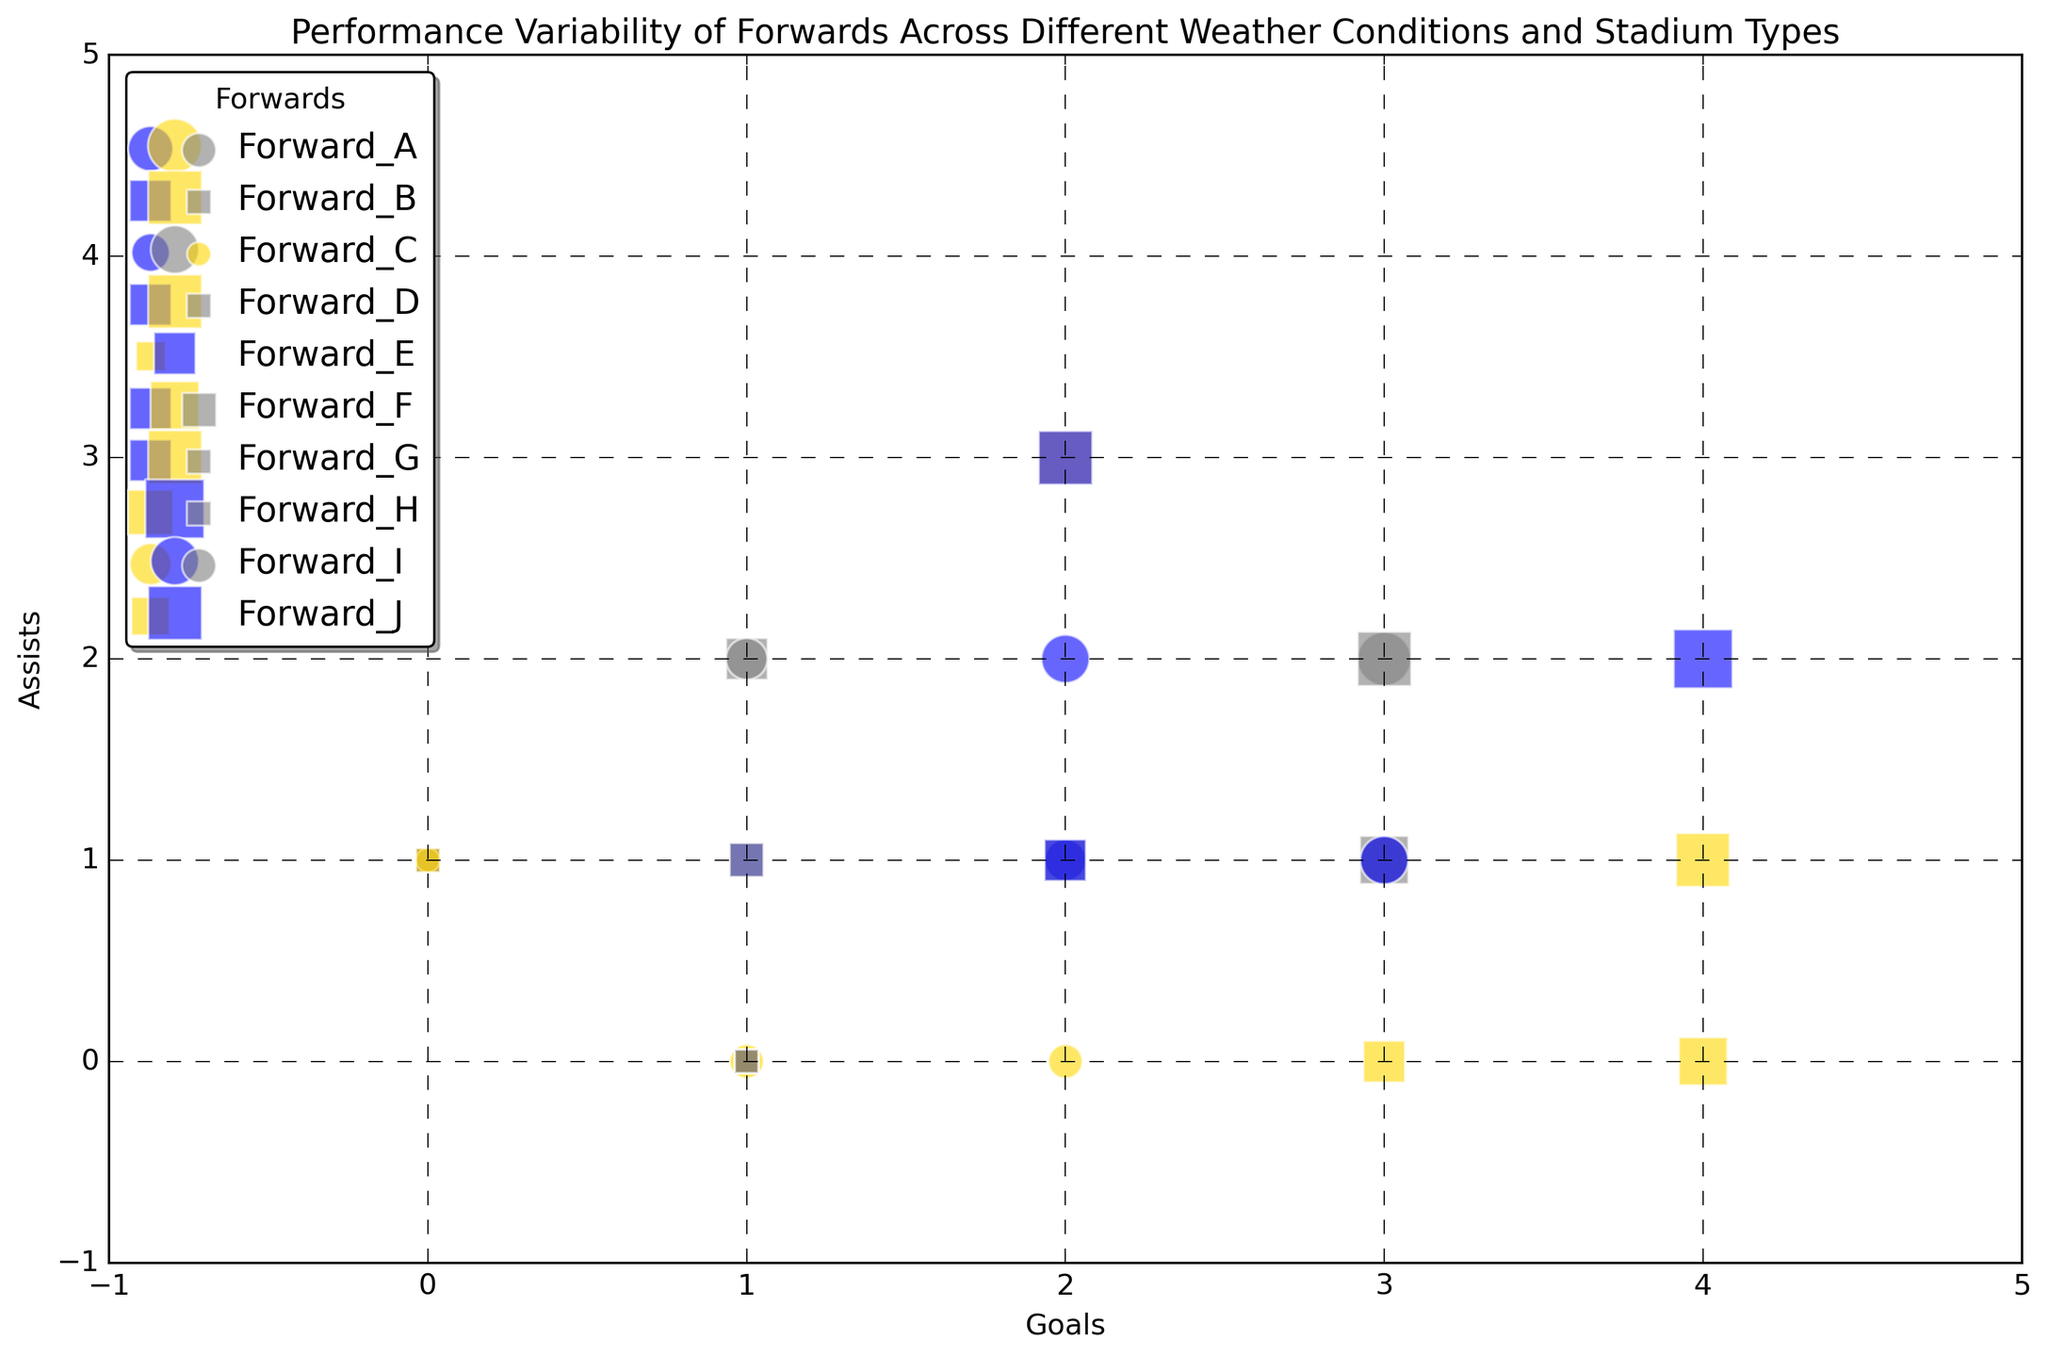what is the total number of goals scored by Forward_B? Sum the goals scored by Forward_B across all matches. Forward_B scores 0 goals in Rain, 4 in Sunny, and 1 in Cloudy, making it 0 + 4 + 1 = 5 goals.
Answer: 5 Which forward has the largest bubble size when the weather is sunny? Look for the forward with the largest bubble size in the sunny weather condition in the plot. Forward_H has the largest bubble size of 6.
Answer: Forward_H Which forward performs better in high match importance, Forward_B or Forward_I? Compare the number of goals and assists scored by Forward_B and Forward_I in high match importance matches. Forward_B scores 4 goals and 1 assist, while Forward_I scores 3 goals and 1 assist. Thus, Forward_B performs better.
Answer: Forward_B What is the average number of assists in Open stadiums during Cloudy weather? Filter the data to only include Open stadiums and Cloudy weather, then average the assists. The forwards' assists are as follows: Forward_A (2), Forward_C (1), Forward_G (1), Forward_I (2). Sum: 2 + 1 + 1 + 2 = 6. Average: 6/4 = 1.5.
Answer: 1.5 Which forward has the highest goals+assists when playing in Closed stadiums under Rainy conditions? Sum the number of goals and assists for each forward in Closed stadiums with Rainy weather. Forward_G has the highest sum (2 goals + 3 assists = 5).
Answer: Forward_G Is there a forward who scores no goals and no assists in any match? Check the bubble size and the goals and assists columns for each match. Forward_J has a match with 0 goals and 0 assists in Sunny conditions in a Closed stadium with high match importance.
Answer: Yes How does the performance of Forward_D vary with different weather conditions in terms of assists? Check the number of assists Forward_D makes under different weather conditions. Forward_D has 0 assists in Rain, 3 in Sunny, and 2 in Cloudy. Assists are highest during Sunny weather.
Answer: Highest in Sunny What is the difference in goals scored by Forward_E and Forward_F in Open stadiums under Sunny weather? Subtract Forward_F's goals from Forward_E's goals in Open stadiums with Sunny weather. Forward_F scores 4 goals, and Forward_E scores 2 goals. Difference: 4 - 2 = 2.
Answer: 2 